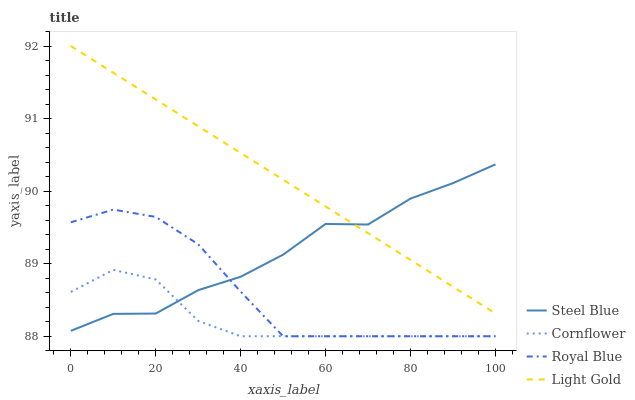Does Cornflower have the minimum area under the curve?
Answer yes or no. Yes. Does Light Gold have the maximum area under the curve?
Answer yes or no. Yes. Does Steel Blue have the minimum area under the curve?
Answer yes or no. No. Does Steel Blue have the maximum area under the curve?
Answer yes or no. No. Is Light Gold the smoothest?
Answer yes or no. Yes. Is Steel Blue the roughest?
Answer yes or no. Yes. Is Steel Blue the smoothest?
Answer yes or no. No. Is Light Gold the roughest?
Answer yes or no. No. Does Cornflower have the lowest value?
Answer yes or no. Yes. Does Steel Blue have the lowest value?
Answer yes or no. No. Does Light Gold have the highest value?
Answer yes or no. Yes. Does Steel Blue have the highest value?
Answer yes or no. No. Is Royal Blue less than Light Gold?
Answer yes or no. Yes. Is Light Gold greater than Cornflower?
Answer yes or no. Yes. Does Steel Blue intersect Cornflower?
Answer yes or no. Yes. Is Steel Blue less than Cornflower?
Answer yes or no. No. Is Steel Blue greater than Cornflower?
Answer yes or no. No. Does Royal Blue intersect Light Gold?
Answer yes or no. No. 